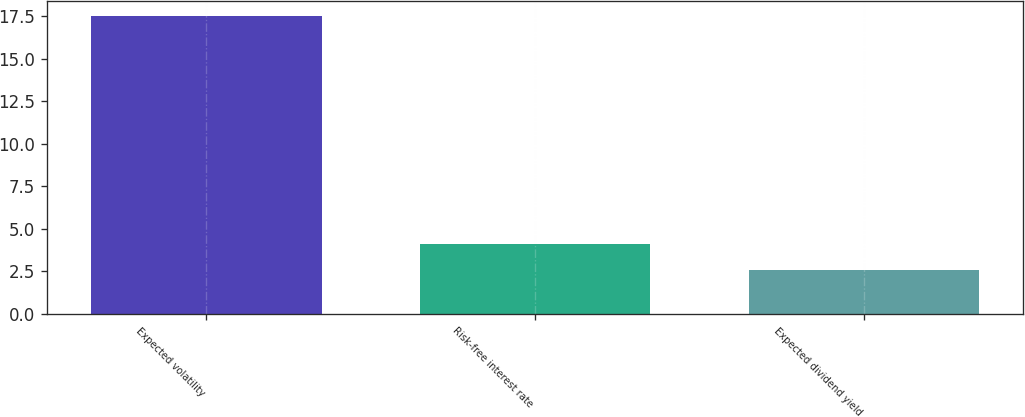<chart> <loc_0><loc_0><loc_500><loc_500><bar_chart><fcel>Expected volatility<fcel>Risk-free interest rate<fcel>Expected dividend yield<nl><fcel>17.5<fcel>4.09<fcel>2.6<nl></chart> 